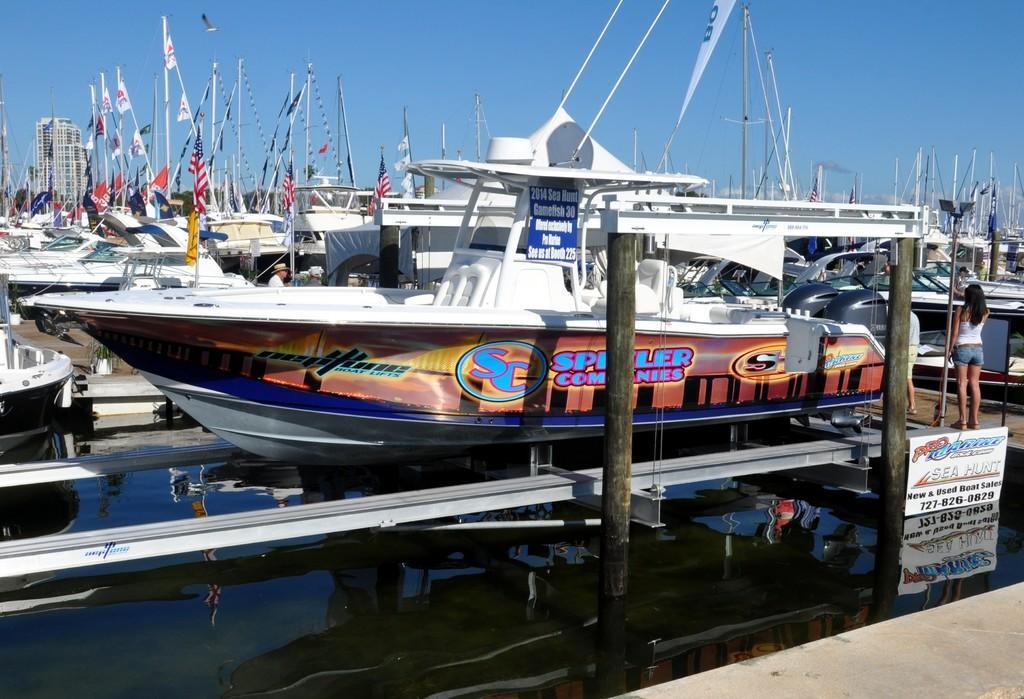Please provide a concise description of this image. This is an outside view. In this image I can see many boats. On the left side, I can see the water. On the right side there are two persons standing on a wooden plank and there is a board on which I can see some text. In the background there is a building. At the top of the image I can see the sky. 